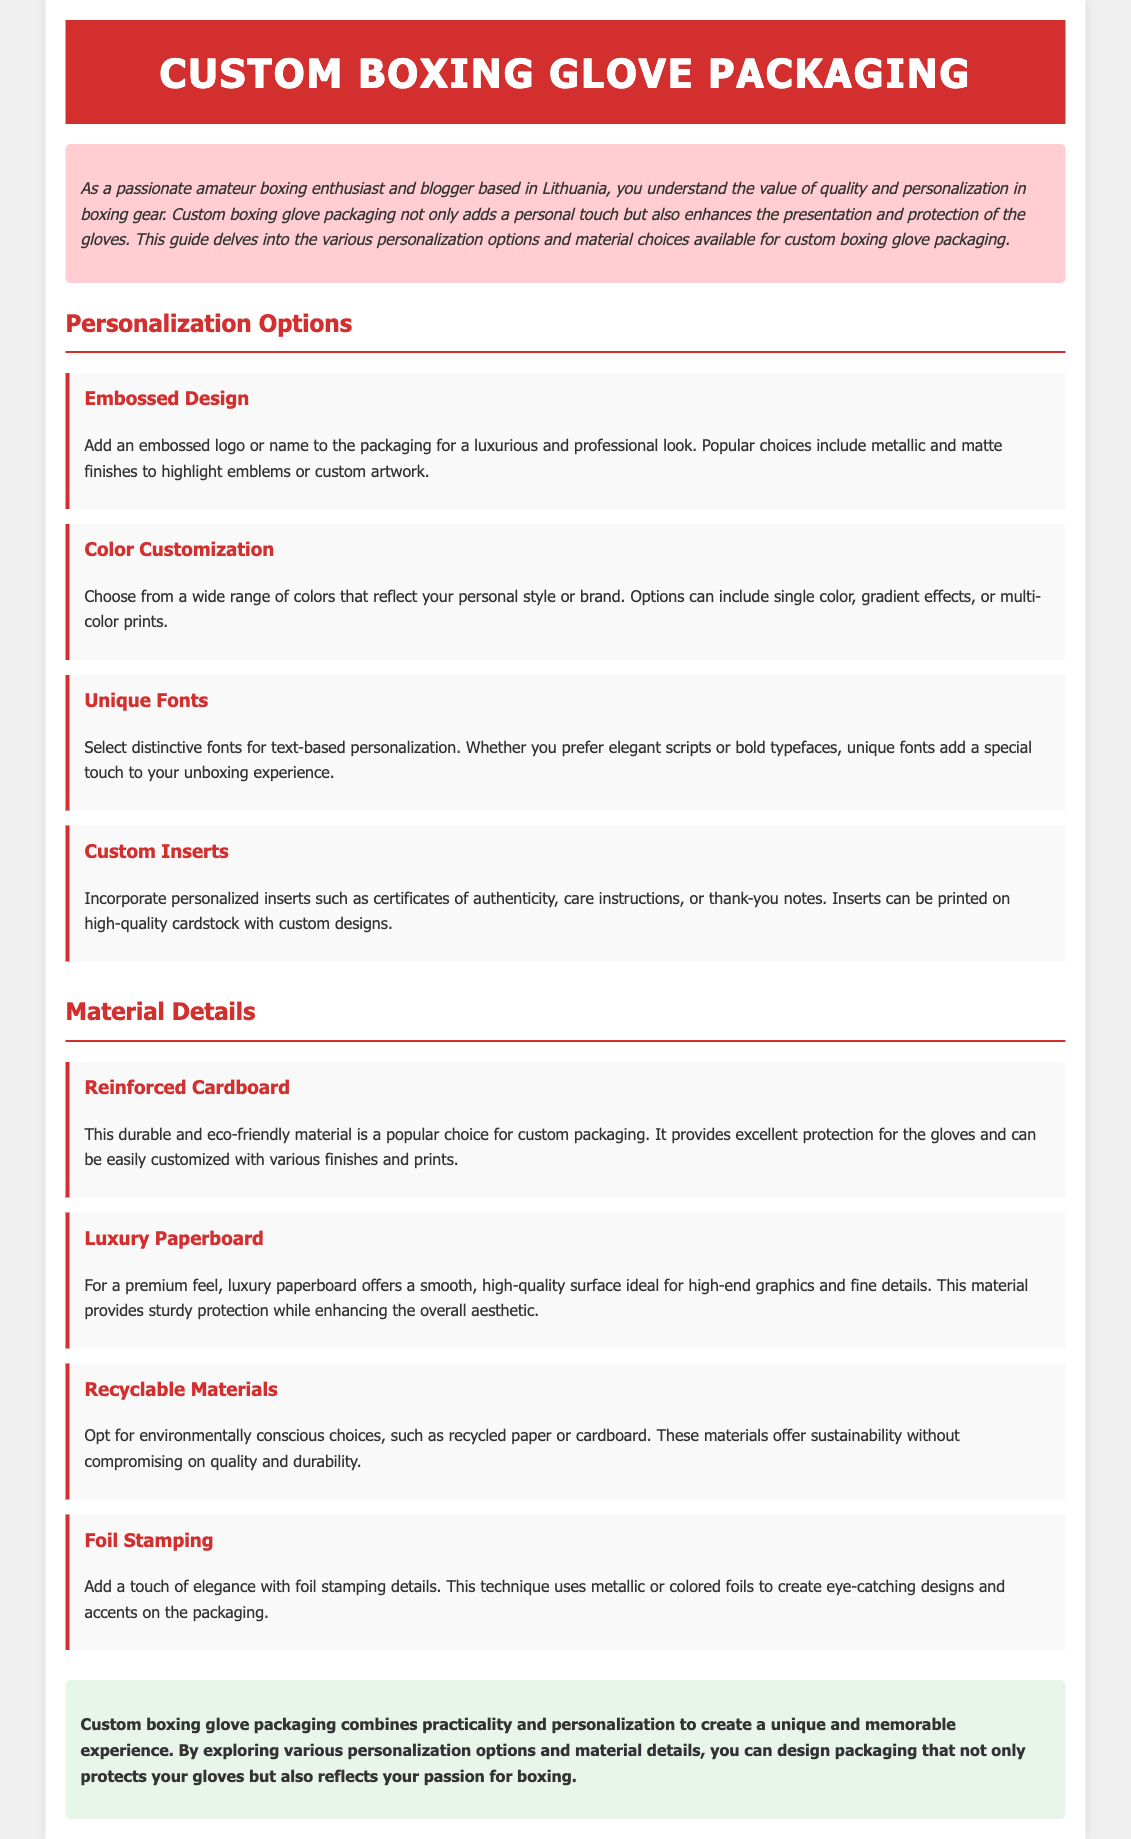What are the personalization options available? The personalization options listed in the document include: Embossed Design, Color Customization, Unique Fonts, and Custom Inserts.
Answer: Embossed Design, Color Customization, Unique Fonts, Custom Inserts What is a key feature of reinforced cardboard? The document states that reinforced cardboard provides excellent protection for the gloves and is an eco-friendly material.
Answer: Excellent protection, eco-friendly Which material offers a premium feel? The document specifically mentions luxury paperboard as providing a premium feel.
Answer: Luxury paperboard How many personalization options are mentioned in the document? The document lists four personalization options.
Answer: Four What is the purpose of custom inserts? According to the document, custom inserts such as certificates of authenticity or thank-you notes add personalization to the packaging.
Answer: Adding personalization What technique is used for creating eye-catching designs on packaging? The document describes foil stamping as a technique that uses metallic or colored foils for designs.
Answer: Foil stamping What color theme is used for the header of the document? The header is described as having a background color of #d32f2f.
Answer: #d32f2f What is the purpose of custom packaging for boxing gloves? The document states that custom boxing glove packaging combines practicality and personalization to create a unique experience.
Answer: Practicality and personalization 